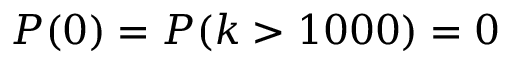Convert formula to latex. <formula><loc_0><loc_0><loc_500><loc_500>P ( 0 ) = P ( k > 1 0 0 0 ) = 0</formula> 